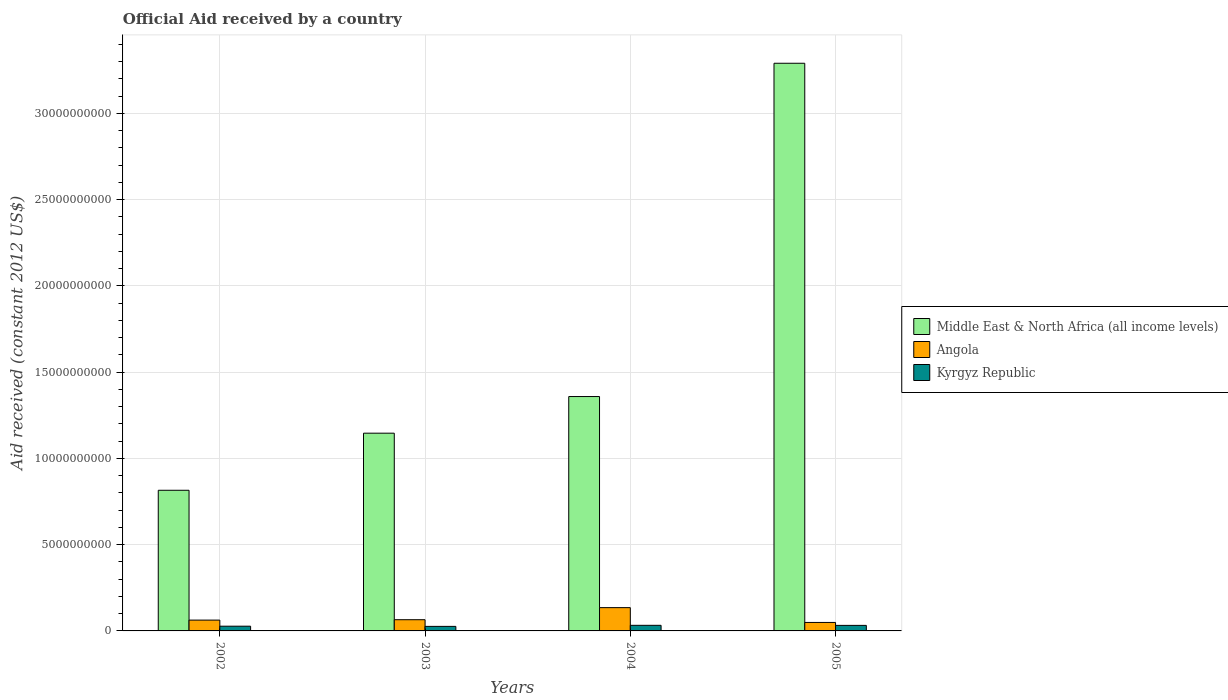How many different coloured bars are there?
Your answer should be compact. 3. Are the number of bars per tick equal to the number of legend labels?
Make the answer very short. Yes. Are the number of bars on each tick of the X-axis equal?
Keep it short and to the point. Yes. How many bars are there on the 3rd tick from the right?
Give a very brief answer. 3. What is the net official aid received in Kyrgyz Republic in 2003?
Offer a terse response. 2.63e+08. Across all years, what is the maximum net official aid received in Angola?
Make the answer very short. 1.35e+09. Across all years, what is the minimum net official aid received in Middle East & North Africa (all income levels)?
Offer a very short reply. 8.15e+09. In which year was the net official aid received in Kyrgyz Republic maximum?
Your answer should be very brief. 2004. In which year was the net official aid received in Kyrgyz Republic minimum?
Make the answer very short. 2003. What is the total net official aid received in Middle East & North Africa (all income levels) in the graph?
Give a very brief answer. 6.61e+1. What is the difference between the net official aid received in Middle East & North Africa (all income levels) in 2003 and that in 2005?
Your answer should be compact. -2.14e+1. What is the difference between the net official aid received in Middle East & North Africa (all income levels) in 2005 and the net official aid received in Kyrgyz Republic in 2004?
Ensure brevity in your answer.  3.26e+1. What is the average net official aid received in Angola per year?
Give a very brief answer. 7.80e+08. In the year 2003, what is the difference between the net official aid received in Middle East & North Africa (all income levels) and net official aid received in Kyrgyz Republic?
Offer a terse response. 1.12e+1. In how many years, is the net official aid received in Kyrgyz Republic greater than 8000000000 US$?
Offer a terse response. 0. What is the ratio of the net official aid received in Middle East & North Africa (all income levels) in 2003 to that in 2004?
Provide a succinct answer. 0.84. What is the difference between the highest and the second highest net official aid received in Angola?
Provide a short and direct response. 7.00e+08. What is the difference between the highest and the lowest net official aid received in Angola?
Keep it short and to the point. 8.59e+08. In how many years, is the net official aid received in Kyrgyz Republic greater than the average net official aid received in Kyrgyz Republic taken over all years?
Your answer should be very brief. 2. Is the sum of the net official aid received in Middle East & North Africa (all income levels) in 2004 and 2005 greater than the maximum net official aid received in Kyrgyz Republic across all years?
Offer a very short reply. Yes. What does the 2nd bar from the left in 2003 represents?
Keep it short and to the point. Angola. What does the 1st bar from the right in 2004 represents?
Give a very brief answer. Kyrgyz Republic. Is it the case that in every year, the sum of the net official aid received in Angola and net official aid received in Kyrgyz Republic is greater than the net official aid received in Middle East & North Africa (all income levels)?
Keep it short and to the point. No. How many bars are there?
Make the answer very short. 12. Are all the bars in the graph horizontal?
Your response must be concise. No. How many years are there in the graph?
Keep it short and to the point. 4. What is the difference between two consecutive major ticks on the Y-axis?
Provide a succinct answer. 5.00e+09. Are the values on the major ticks of Y-axis written in scientific E-notation?
Make the answer very short. No. Does the graph contain any zero values?
Provide a succinct answer. No. Where does the legend appear in the graph?
Give a very brief answer. Center right. What is the title of the graph?
Your answer should be very brief. Official Aid received by a country. What is the label or title of the X-axis?
Keep it short and to the point. Years. What is the label or title of the Y-axis?
Make the answer very short. Aid received (constant 2012 US$). What is the Aid received (constant 2012 US$) of Middle East & North Africa (all income levels) in 2002?
Offer a terse response. 8.15e+09. What is the Aid received (constant 2012 US$) of Angola in 2002?
Your answer should be compact. 6.27e+08. What is the Aid received (constant 2012 US$) in Kyrgyz Republic in 2002?
Ensure brevity in your answer.  2.74e+08. What is the Aid received (constant 2012 US$) of Middle East & North Africa (all income levels) in 2003?
Give a very brief answer. 1.15e+1. What is the Aid received (constant 2012 US$) in Angola in 2003?
Keep it short and to the point. 6.50e+08. What is the Aid received (constant 2012 US$) in Kyrgyz Republic in 2003?
Offer a terse response. 2.63e+08. What is the Aid received (constant 2012 US$) of Middle East & North Africa (all income levels) in 2004?
Your answer should be very brief. 1.36e+1. What is the Aid received (constant 2012 US$) of Angola in 2004?
Offer a terse response. 1.35e+09. What is the Aid received (constant 2012 US$) of Kyrgyz Republic in 2004?
Provide a short and direct response. 3.25e+08. What is the Aid received (constant 2012 US$) in Middle East & North Africa (all income levels) in 2005?
Your answer should be very brief. 3.29e+1. What is the Aid received (constant 2012 US$) in Angola in 2005?
Your answer should be very brief. 4.91e+08. What is the Aid received (constant 2012 US$) of Kyrgyz Republic in 2005?
Offer a very short reply. 3.21e+08. Across all years, what is the maximum Aid received (constant 2012 US$) of Middle East & North Africa (all income levels)?
Keep it short and to the point. 3.29e+1. Across all years, what is the maximum Aid received (constant 2012 US$) in Angola?
Your answer should be very brief. 1.35e+09. Across all years, what is the maximum Aid received (constant 2012 US$) in Kyrgyz Republic?
Your answer should be compact. 3.25e+08. Across all years, what is the minimum Aid received (constant 2012 US$) of Middle East & North Africa (all income levels)?
Ensure brevity in your answer.  8.15e+09. Across all years, what is the minimum Aid received (constant 2012 US$) of Angola?
Make the answer very short. 4.91e+08. Across all years, what is the minimum Aid received (constant 2012 US$) in Kyrgyz Republic?
Ensure brevity in your answer.  2.63e+08. What is the total Aid received (constant 2012 US$) of Middle East & North Africa (all income levels) in the graph?
Your answer should be very brief. 6.61e+1. What is the total Aid received (constant 2012 US$) in Angola in the graph?
Your response must be concise. 3.12e+09. What is the total Aid received (constant 2012 US$) of Kyrgyz Republic in the graph?
Your answer should be very brief. 1.18e+09. What is the difference between the Aid received (constant 2012 US$) of Middle East & North Africa (all income levels) in 2002 and that in 2003?
Provide a short and direct response. -3.31e+09. What is the difference between the Aid received (constant 2012 US$) of Angola in 2002 and that in 2003?
Your answer should be compact. -2.27e+07. What is the difference between the Aid received (constant 2012 US$) in Kyrgyz Republic in 2002 and that in 2003?
Give a very brief answer. 1.09e+07. What is the difference between the Aid received (constant 2012 US$) of Middle East & North Africa (all income levels) in 2002 and that in 2004?
Ensure brevity in your answer.  -5.43e+09. What is the difference between the Aid received (constant 2012 US$) in Angola in 2002 and that in 2004?
Make the answer very short. -7.23e+08. What is the difference between the Aid received (constant 2012 US$) of Kyrgyz Republic in 2002 and that in 2004?
Offer a terse response. -5.12e+07. What is the difference between the Aid received (constant 2012 US$) of Middle East & North Africa (all income levels) in 2002 and that in 2005?
Your answer should be very brief. -2.48e+1. What is the difference between the Aid received (constant 2012 US$) in Angola in 2002 and that in 2005?
Keep it short and to the point. 1.36e+08. What is the difference between the Aid received (constant 2012 US$) of Kyrgyz Republic in 2002 and that in 2005?
Provide a succinct answer. -4.73e+07. What is the difference between the Aid received (constant 2012 US$) of Middle East & North Africa (all income levels) in 2003 and that in 2004?
Offer a terse response. -2.12e+09. What is the difference between the Aid received (constant 2012 US$) in Angola in 2003 and that in 2004?
Offer a very short reply. -7.00e+08. What is the difference between the Aid received (constant 2012 US$) of Kyrgyz Republic in 2003 and that in 2004?
Your answer should be compact. -6.22e+07. What is the difference between the Aid received (constant 2012 US$) in Middle East & North Africa (all income levels) in 2003 and that in 2005?
Your answer should be compact. -2.14e+1. What is the difference between the Aid received (constant 2012 US$) of Angola in 2003 and that in 2005?
Offer a very short reply. 1.59e+08. What is the difference between the Aid received (constant 2012 US$) of Kyrgyz Republic in 2003 and that in 2005?
Provide a succinct answer. -5.82e+07. What is the difference between the Aid received (constant 2012 US$) in Middle East & North Africa (all income levels) in 2004 and that in 2005?
Your answer should be compact. -1.93e+1. What is the difference between the Aid received (constant 2012 US$) in Angola in 2004 and that in 2005?
Provide a short and direct response. 8.59e+08. What is the difference between the Aid received (constant 2012 US$) of Kyrgyz Republic in 2004 and that in 2005?
Make the answer very short. 3.94e+06. What is the difference between the Aid received (constant 2012 US$) in Middle East & North Africa (all income levels) in 2002 and the Aid received (constant 2012 US$) in Angola in 2003?
Your answer should be compact. 7.50e+09. What is the difference between the Aid received (constant 2012 US$) of Middle East & North Africa (all income levels) in 2002 and the Aid received (constant 2012 US$) of Kyrgyz Republic in 2003?
Make the answer very short. 7.89e+09. What is the difference between the Aid received (constant 2012 US$) of Angola in 2002 and the Aid received (constant 2012 US$) of Kyrgyz Republic in 2003?
Your answer should be very brief. 3.65e+08. What is the difference between the Aid received (constant 2012 US$) in Middle East & North Africa (all income levels) in 2002 and the Aid received (constant 2012 US$) in Angola in 2004?
Give a very brief answer. 6.80e+09. What is the difference between the Aid received (constant 2012 US$) in Middle East & North Africa (all income levels) in 2002 and the Aid received (constant 2012 US$) in Kyrgyz Republic in 2004?
Offer a terse response. 7.83e+09. What is the difference between the Aid received (constant 2012 US$) in Angola in 2002 and the Aid received (constant 2012 US$) in Kyrgyz Republic in 2004?
Offer a terse response. 3.02e+08. What is the difference between the Aid received (constant 2012 US$) in Middle East & North Africa (all income levels) in 2002 and the Aid received (constant 2012 US$) in Angola in 2005?
Provide a succinct answer. 7.66e+09. What is the difference between the Aid received (constant 2012 US$) of Middle East & North Africa (all income levels) in 2002 and the Aid received (constant 2012 US$) of Kyrgyz Republic in 2005?
Ensure brevity in your answer.  7.83e+09. What is the difference between the Aid received (constant 2012 US$) in Angola in 2002 and the Aid received (constant 2012 US$) in Kyrgyz Republic in 2005?
Give a very brief answer. 3.06e+08. What is the difference between the Aid received (constant 2012 US$) in Middle East & North Africa (all income levels) in 2003 and the Aid received (constant 2012 US$) in Angola in 2004?
Ensure brevity in your answer.  1.01e+1. What is the difference between the Aid received (constant 2012 US$) in Middle East & North Africa (all income levels) in 2003 and the Aid received (constant 2012 US$) in Kyrgyz Republic in 2004?
Provide a short and direct response. 1.11e+1. What is the difference between the Aid received (constant 2012 US$) of Angola in 2003 and the Aid received (constant 2012 US$) of Kyrgyz Republic in 2004?
Make the answer very short. 3.25e+08. What is the difference between the Aid received (constant 2012 US$) of Middle East & North Africa (all income levels) in 2003 and the Aid received (constant 2012 US$) of Angola in 2005?
Keep it short and to the point. 1.10e+1. What is the difference between the Aid received (constant 2012 US$) of Middle East & North Africa (all income levels) in 2003 and the Aid received (constant 2012 US$) of Kyrgyz Republic in 2005?
Your answer should be very brief. 1.11e+1. What is the difference between the Aid received (constant 2012 US$) in Angola in 2003 and the Aid received (constant 2012 US$) in Kyrgyz Republic in 2005?
Make the answer very short. 3.29e+08. What is the difference between the Aid received (constant 2012 US$) in Middle East & North Africa (all income levels) in 2004 and the Aid received (constant 2012 US$) in Angola in 2005?
Keep it short and to the point. 1.31e+1. What is the difference between the Aid received (constant 2012 US$) of Middle East & North Africa (all income levels) in 2004 and the Aid received (constant 2012 US$) of Kyrgyz Republic in 2005?
Offer a very short reply. 1.33e+1. What is the difference between the Aid received (constant 2012 US$) in Angola in 2004 and the Aid received (constant 2012 US$) in Kyrgyz Republic in 2005?
Ensure brevity in your answer.  1.03e+09. What is the average Aid received (constant 2012 US$) of Middle East & North Africa (all income levels) per year?
Your answer should be compact. 1.65e+1. What is the average Aid received (constant 2012 US$) in Angola per year?
Your response must be concise. 7.80e+08. What is the average Aid received (constant 2012 US$) in Kyrgyz Republic per year?
Make the answer very short. 2.96e+08. In the year 2002, what is the difference between the Aid received (constant 2012 US$) in Middle East & North Africa (all income levels) and Aid received (constant 2012 US$) in Angola?
Offer a very short reply. 7.53e+09. In the year 2002, what is the difference between the Aid received (constant 2012 US$) of Middle East & North Africa (all income levels) and Aid received (constant 2012 US$) of Kyrgyz Republic?
Offer a terse response. 7.88e+09. In the year 2002, what is the difference between the Aid received (constant 2012 US$) in Angola and Aid received (constant 2012 US$) in Kyrgyz Republic?
Provide a succinct answer. 3.54e+08. In the year 2003, what is the difference between the Aid received (constant 2012 US$) in Middle East & North Africa (all income levels) and Aid received (constant 2012 US$) in Angola?
Provide a short and direct response. 1.08e+1. In the year 2003, what is the difference between the Aid received (constant 2012 US$) of Middle East & North Africa (all income levels) and Aid received (constant 2012 US$) of Kyrgyz Republic?
Offer a terse response. 1.12e+1. In the year 2003, what is the difference between the Aid received (constant 2012 US$) in Angola and Aid received (constant 2012 US$) in Kyrgyz Republic?
Give a very brief answer. 3.87e+08. In the year 2004, what is the difference between the Aid received (constant 2012 US$) of Middle East & North Africa (all income levels) and Aid received (constant 2012 US$) of Angola?
Offer a terse response. 1.22e+1. In the year 2004, what is the difference between the Aid received (constant 2012 US$) of Middle East & North Africa (all income levels) and Aid received (constant 2012 US$) of Kyrgyz Republic?
Provide a short and direct response. 1.33e+1. In the year 2004, what is the difference between the Aid received (constant 2012 US$) of Angola and Aid received (constant 2012 US$) of Kyrgyz Republic?
Your answer should be compact. 1.03e+09. In the year 2005, what is the difference between the Aid received (constant 2012 US$) of Middle East & North Africa (all income levels) and Aid received (constant 2012 US$) of Angola?
Make the answer very short. 3.24e+1. In the year 2005, what is the difference between the Aid received (constant 2012 US$) in Middle East & North Africa (all income levels) and Aid received (constant 2012 US$) in Kyrgyz Republic?
Your response must be concise. 3.26e+1. In the year 2005, what is the difference between the Aid received (constant 2012 US$) in Angola and Aid received (constant 2012 US$) in Kyrgyz Republic?
Provide a succinct answer. 1.70e+08. What is the ratio of the Aid received (constant 2012 US$) of Middle East & North Africa (all income levels) in 2002 to that in 2003?
Provide a succinct answer. 0.71. What is the ratio of the Aid received (constant 2012 US$) of Angola in 2002 to that in 2003?
Provide a succinct answer. 0.96. What is the ratio of the Aid received (constant 2012 US$) of Kyrgyz Republic in 2002 to that in 2003?
Offer a terse response. 1.04. What is the ratio of the Aid received (constant 2012 US$) in Middle East & North Africa (all income levels) in 2002 to that in 2004?
Your response must be concise. 0.6. What is the ratio of the Aid received (constant 2012 US$) of Angola in 2002 to that in 2004?
Ensure brevity in your answer.  0.46. What is the ratio of the Aid received (constant 2012 US$) in Kyrgyz Republic in 2002 to that in 2004?
Keep it short and to the point. 0.84. What is the ratio of the Aid received (constant 2012 US$) of Middle East & North Africa (all income levels) in 2002 to that in 2005?
Give a very brief answer. 0.25. What is the ratio of the Aid received (constant 2012 US$) of Angola in 2002 to that in 2005?
Make the answer very short. 1.28. What is the ratio of the Aid received (constant 2012 US$) of Kyrgyz Republic in 2002 to that in 2005?
Provide a short and direct response. 0.85. What is the ratio of the Aid received (constant 2012 US$) in Middle East & North Africa (all income levels) in 2003 to that in 2004?
Offer a terse response. 0.84. What is the ratio of the Aid received (constant 2012 US$) of Angola in 2003 to that in 2004?
Keep it short and to the point. 0.48. What is the ratio of the Aid received (constant 2012 US$) of Kyrgyz Republic in 2003 to that in 2004?
Your answer should be very brief. 0.81. What is the ratio of the Aid received (constant 2012 US$) of Middle East & North Africa (all income levels) in 2003 to that in 2005?
Give a very brief answer. 0.35. What is the ratio of the Aid received (constant 2012 US$) in Angola in 2003 to that in 2005?
Your response must be concise. 1.32. What is the ratio of the Aid received (constant 2012 US$) of Kyrgyz Republic in 2003 to that in 2005?
Your answer should be very brief. 0.82. What is the ratio of the Aid received (constant 2012 US$) of Middle East & North Africa (all income levels) in 2004 to that in 2005?
Provide a short and direct response. 0.41. What is the ratio of the Aid received (constant 2012 US$) of Angola in 2004 to that in 2005?
Ensure brevity in your answer.  2.75. What is the ratio of the Aid received (constant 2012 US$) in Kyrgyz Republic in 2004 to that in 2005?
Make the answer very short. 1.01. What is the difference between the highest and the second highest Aid received (constant 2012 US$) of Middle East & North Africa (all income levels)?
Offer a terse response. 1.93e+1. What is the difference between the highest and the second highest Aid received (constant 2012 US$) of Angola?
Offer a very short reply. 7.00e+08. What is the difference between the highest and the second highest Aid received (constant 2012 US$) of Kyrgyz Republic?
Your response must be concise. 3.94e+06. What is the difference between the highest and the lowest Aid received (constant 2012 US$) of Middle East & North Africa (all income levels)?
Offer a very short reply. 2.48e+1. What is the difference between the highest and the lowest Aid received (constant 2012 US$) in Angola?
Your answer should be very brief. 8.59e+08. What is the difference between the highest and the lowest Aid received (constant 2012 US$) of Kyrgyz Republic?
Keep it short and to the point. 6.22e+07. 